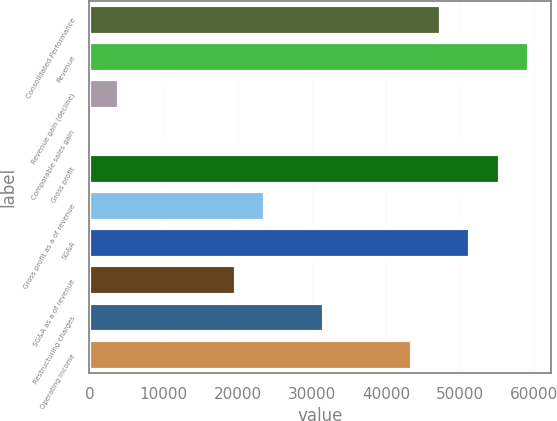Convert chart. <chart><loc_0><loc_0><loc_500><loc_500><bar_chart><fcel>Consolidated Performance<fcel>Revenue<fcel>Revenue gain (decline)<fcel>Comparable sales gain<fcel>Gross profit<fcel>Gross profit as a of revenue<fcel>SG&A<fcel>SG&A as a of revenue<fcel>Restructuring charges<fcel>Operating income<nl><fcel>47433.5<fcel>59291.8<fcel>3953.25<fcel>0.5<fcel>55339<fcel>23717<fcel>51386.2<fcel>19764.2<fcel>31622.5<fcel>43480.8<nl></chart> 